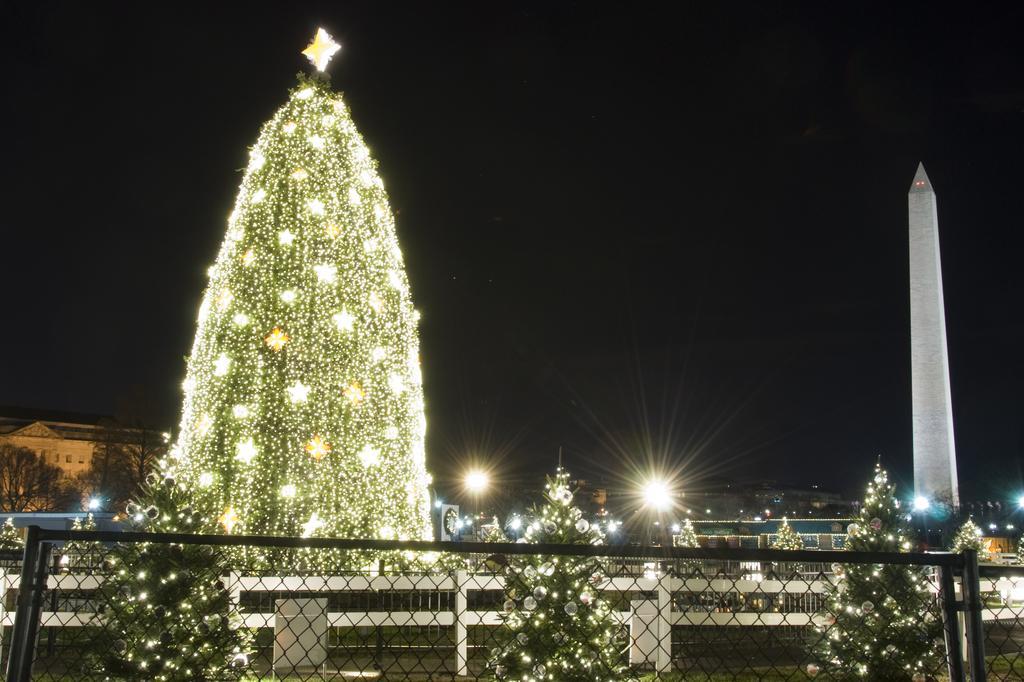In one or two sentences, can you explain what this image depicts? This image consists of a dome on which there are lights. On the right, we can see a tower. At the bottom, there is a fencing made up of metal. In the background, there are buildings along with lights. At the top, there is sky in black color. 